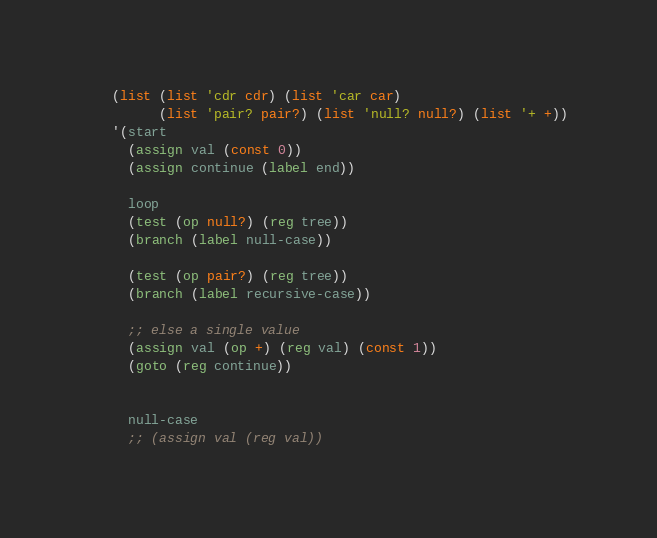Convert code to text. <code><loc_0><loc_0><loc_500><loc_500><_Scheme_>   (list (list 'cdr cdr) (list 'car car)
         (list 'pair? pair?) (list 'null? null?) (list '+ +))
   '(start
     (assign val (const 0))
     (assign continue (label end))

     loop
     (test (op null?) (reg tree))
     (branch (label null-case))

     (test (op pair?) (reg tree))
     (branch (label recursive-case))

     ;; else a single value
     (assign val (op +) (reg val) (const 1))
     (goto (reg continue))


     null-case
     ;; (assign val (reg val))</code> 